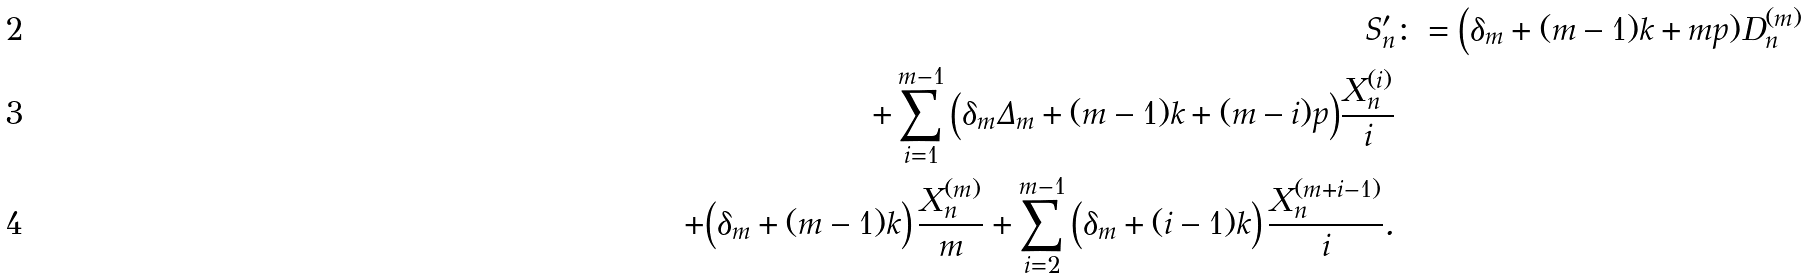Convert formula to latex. <formula><loc_0><loc_0><loc_500><loc_500>S _ { n } ^ { \prime } & \colon = \Big ( \delta _ { m } + ( m - 1 ) k + m p ) { D _ { n } ^ { ( m ) } } \\ + \sum _ { i = 1 } ^ { m - 1 } \Big ( \delta _ { m } \Delta _ { m } + ( m - 1 ) k + ( m - i ) p \Big ) \frac { X _ { n } ^ { ( i ) } } i \\ + \Big ( \delta _ { m } + ( m - 1 ) k \Big ) \, \frac { X _ { n } ^ { ( m ) } } m + \sum _ { i = 2 } ^ { m - 1 } \Big ( \delta _ { m } + ( i - 1 ) k \Big ) \, \frac { X _ { n } ^ { ( m + i - 1 ) } } i .</formula> 